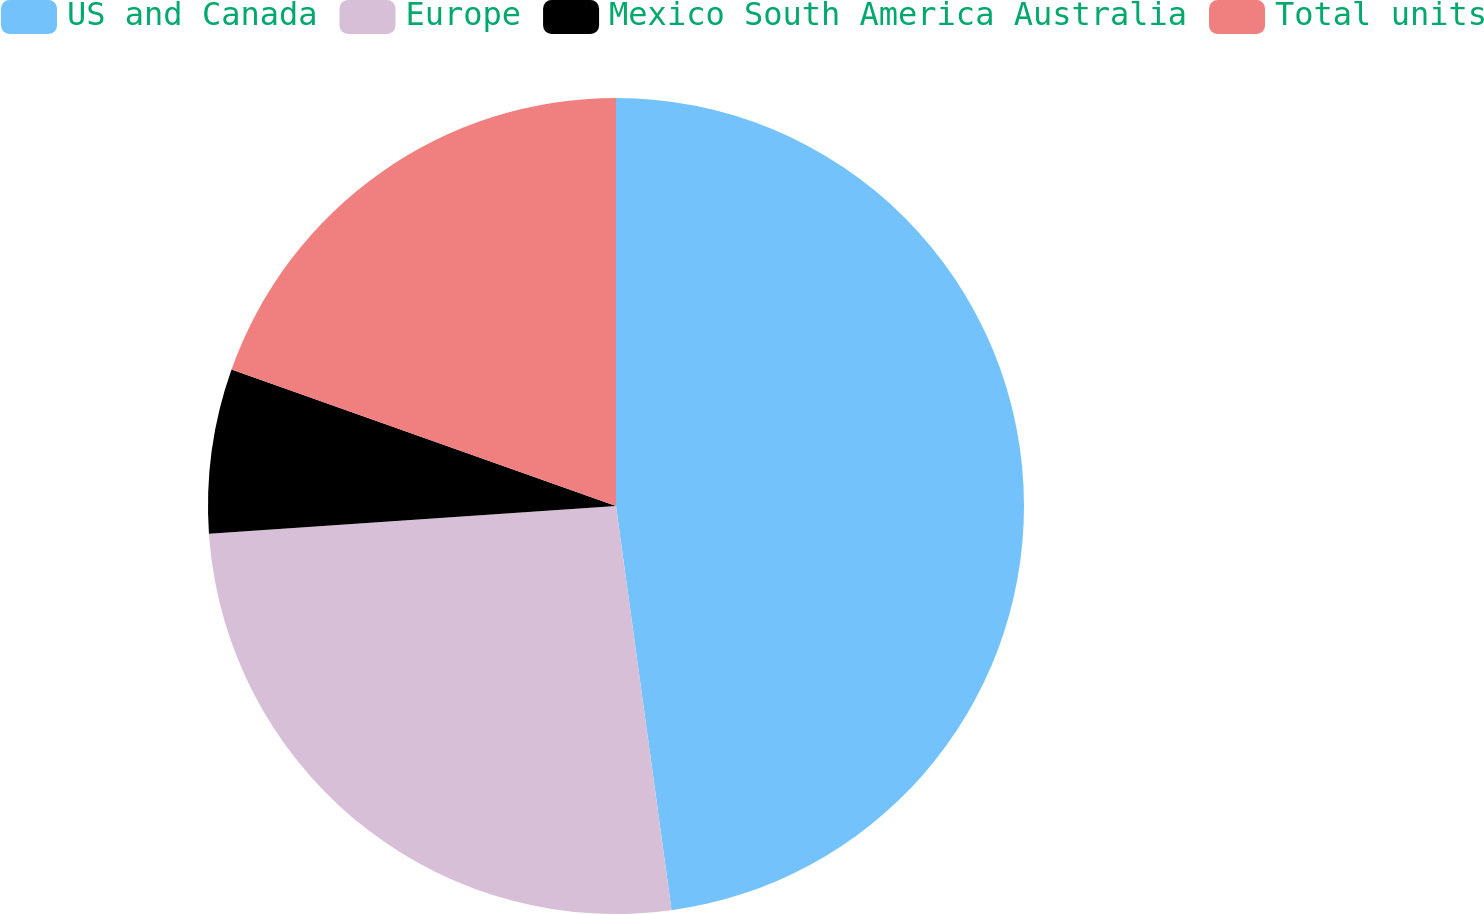<chart> <loc_0><loc_0><loc_500><loc_500><pie_chart><fcel>US and Canada<fcel>Europe<fcel>Mexico South America Australia<fcel>Total units<nl><fcel>47.83%<fcel>26.09%<fcel>6.52%<fcel>19.57%<nl></chart> 